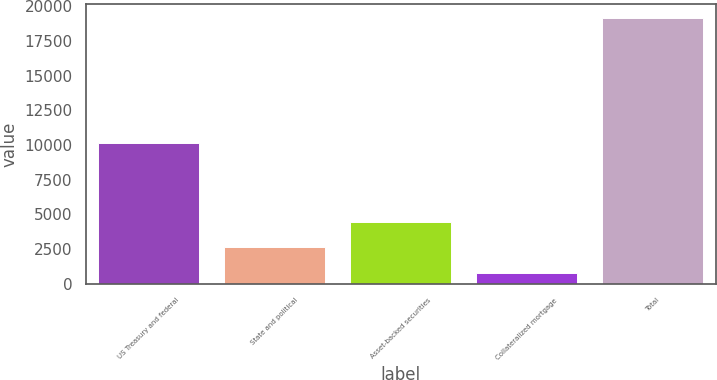<chart> <loc_0><loc_0><loc_500><loc_500><bar_chart><fcel>US Treasury and federal<fcel>State and political<fcel>Asset-backed securities<fcel>Collateralized mortgage<fcel>Total<nl><fcel>10157<fcel>2627.5<fcel>4466<fcel>789<fcel>19174<nl></chart> 